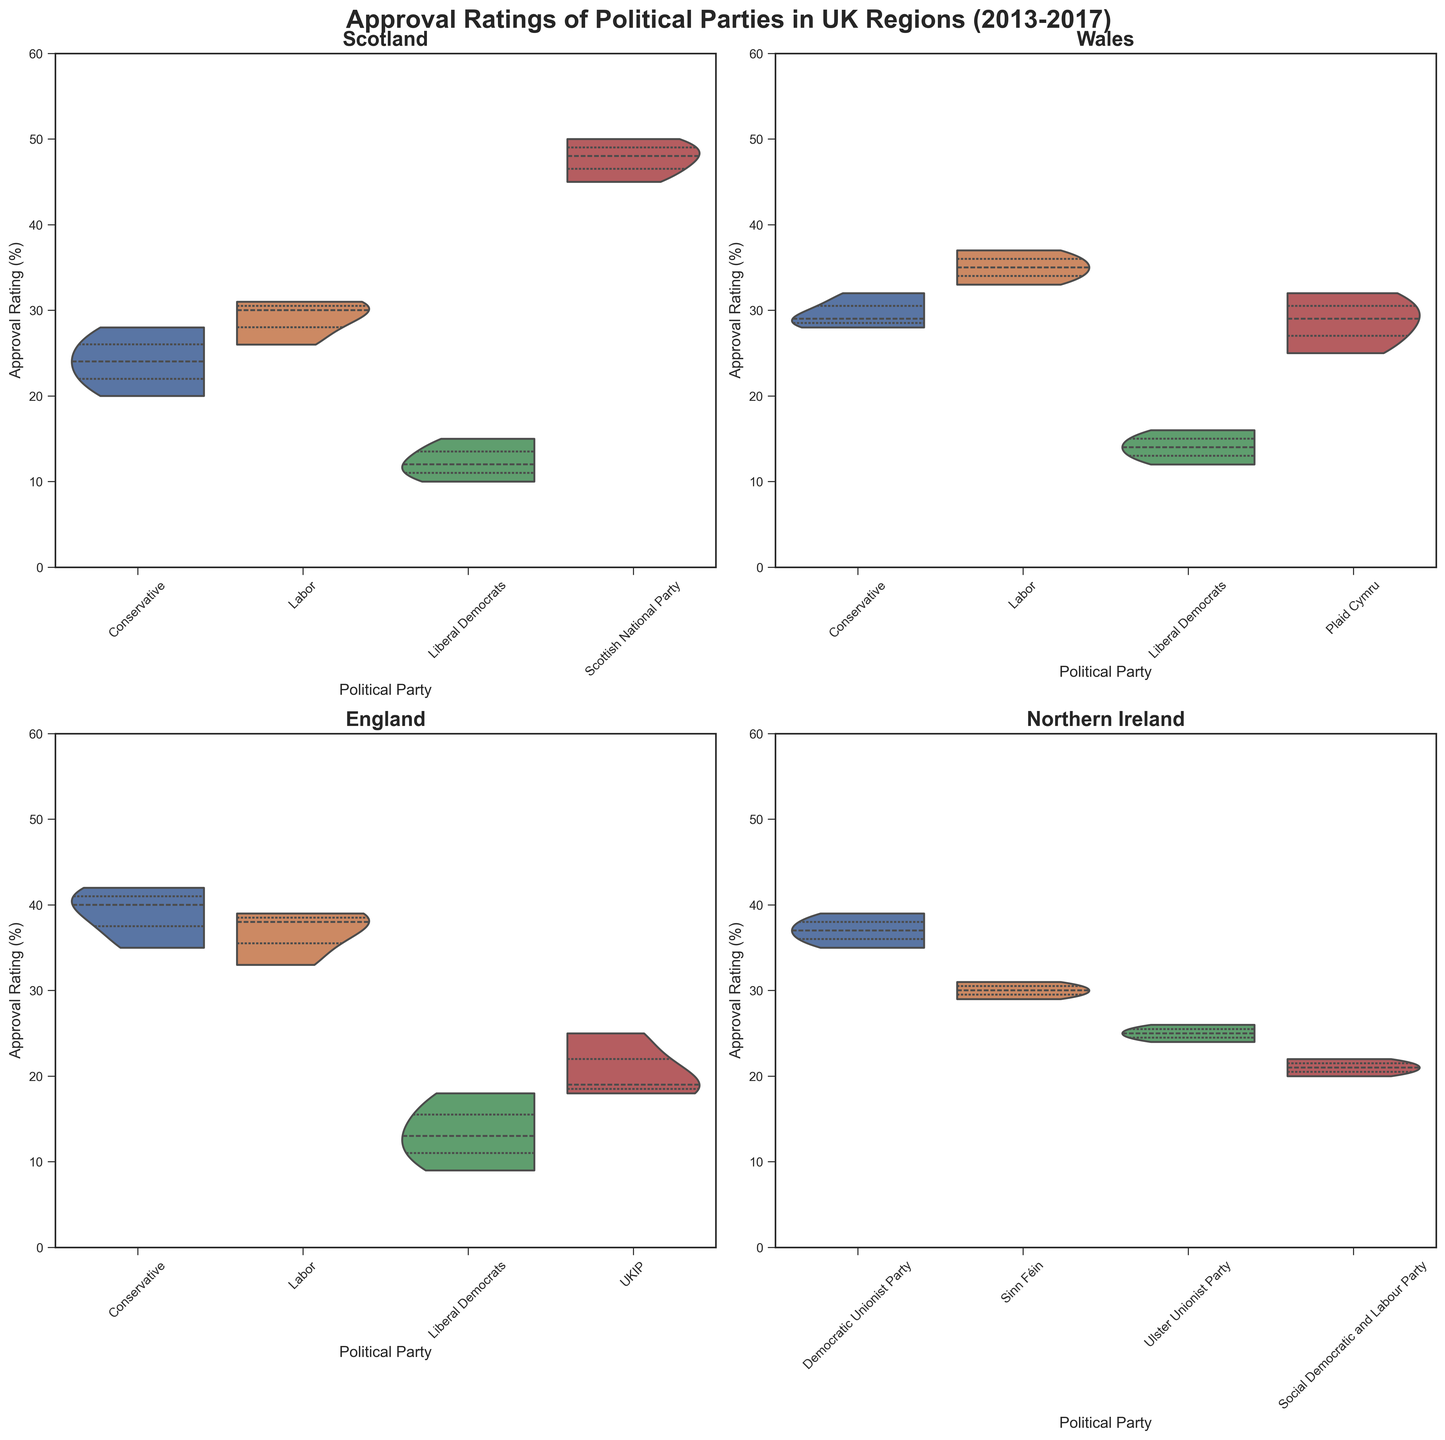How many regions are shown in the figure? The title indicates that the data covers different regions, and the subplots in the figure are divided into 2 rows and 2 columns, making a total of 4 regions: Scotland, Wales, England, and Northern Ireland.
Answer: 4 Which region shows the highest approval rating for any political party in 2017? Looking at the subplots for each region, the highest approval rating in 2017 can be observed in Scotland for the Scottish National Party (SNP) with a rating close to 50%.
Answer: Scotland What is the general trend for approval ratings of the Conservative Party in Wales from 2013 to 2017? By examining the violin plots for Wales, we see they start at an approval rating slightly below 30% in 2013, peak around 32% in 2015, and then drop slightly to around 28% in 2017.
Answer: Slight increase then slight decrease Which political party has the most variation in approval ratings across the regions in 2015? By comparing the width and spread of the violin plots for all parties in 2015 across different regions, the Conservative Party in England has the most variation with a wider spread.
Answer: Conservative Party How does the approval rating of the Labor Party in England compare to that in Wales for the year 2015? By comparing the violin plots for the Labor Party in the England and Wales subplots for the year 2015, we see that the approval rating is higher in Wales (~33%) than in England (~33%).
Answer: Slightly higher in Wales What is the range of approval ratings for the Scottish National Party in Scotland? Observing the split violin plot for Scotland, the Scottish National Party lineup ranges from 45% to close to 50%, remaining fairly high within this short range.
Answer: 45%-50% Did any political party in Northern Ireland have a consistent increase in approval ratings from 2013 to 2017? By observing the trends in the violin plots of Northern Ireland, the Democratic Unionist Party (DUP) shows a consistent increase from 35% in 2013 to 39% in 2017.
Answer: Democratic Unionist Party (DUP) Among all regions, which political party had the lowest median approval rating in 2017? By examining each violin plot for 2017 and identifying median lines, the Liberal Democrats in England show the lowest median approval rating around 9%.
Answer: Liberal Democrats in England 